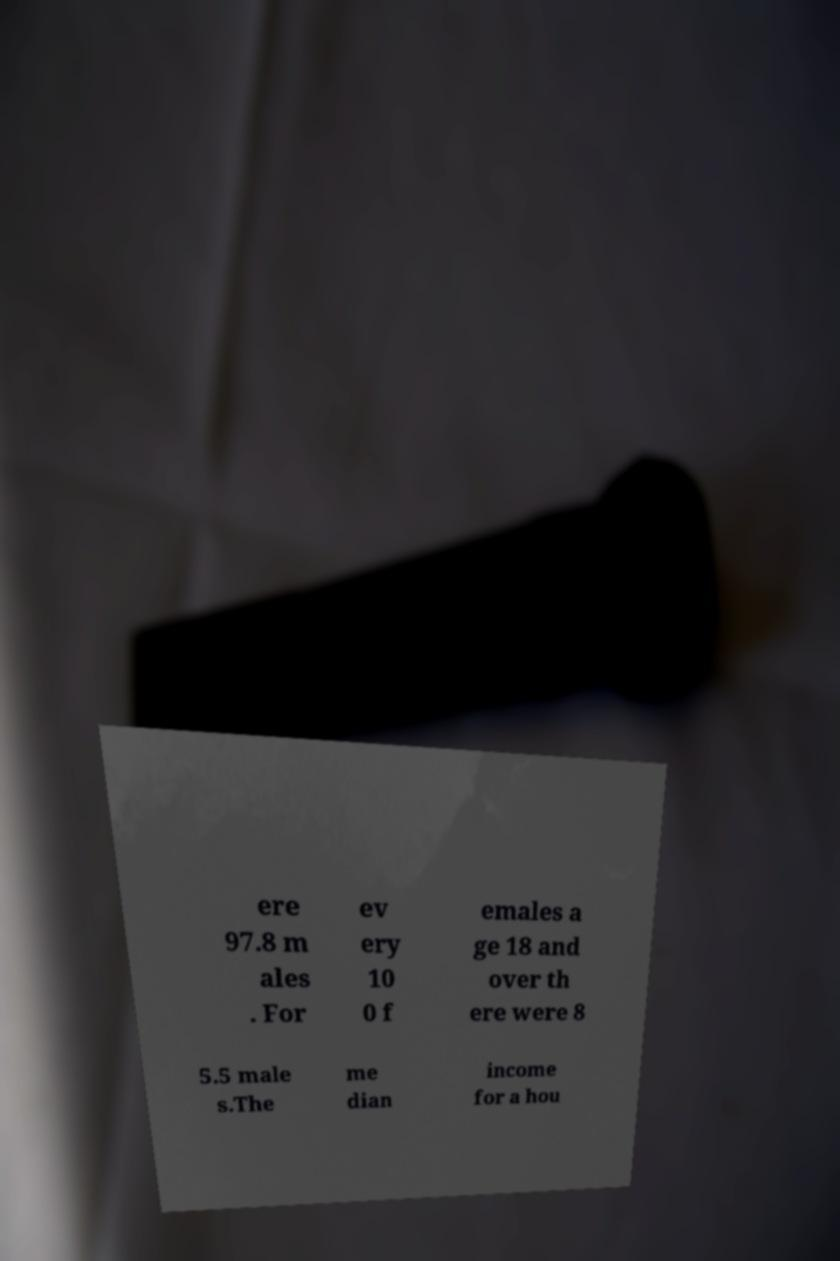Could you assist in decoding the text presented in this image and type it out clearly? ere 97.8 m ales . For ev ery 10 0 f emales a ge 18 and over th ere were 8 5.5 male s.The me dian income for a hou 